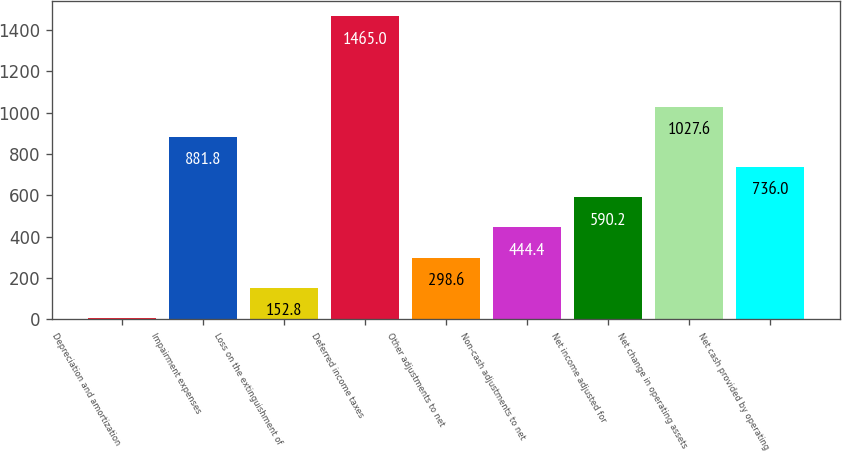Convert chart. <chart><loc_0><loc_0><loc_500><loc_500><bar_chart><fcel>Depreciation and amortization<fcel>Impairment expenses<fcel>Loss on the extinguishment of<fcel>Deferred income taxes<fcel>Other adjustments to net<fcel>Non-cash adjustments to net<fcel>Net income adjusted for<fcel>Net change in operating assets<fcel>Net cash provided by operating<nl><fcel>7<fcel>881.8<fcel>152.8<fcel>1465<fcel>298.6<fcel>444.4<fcel>590.2<fcel>1027.6<fcel>736<nl></chart> 